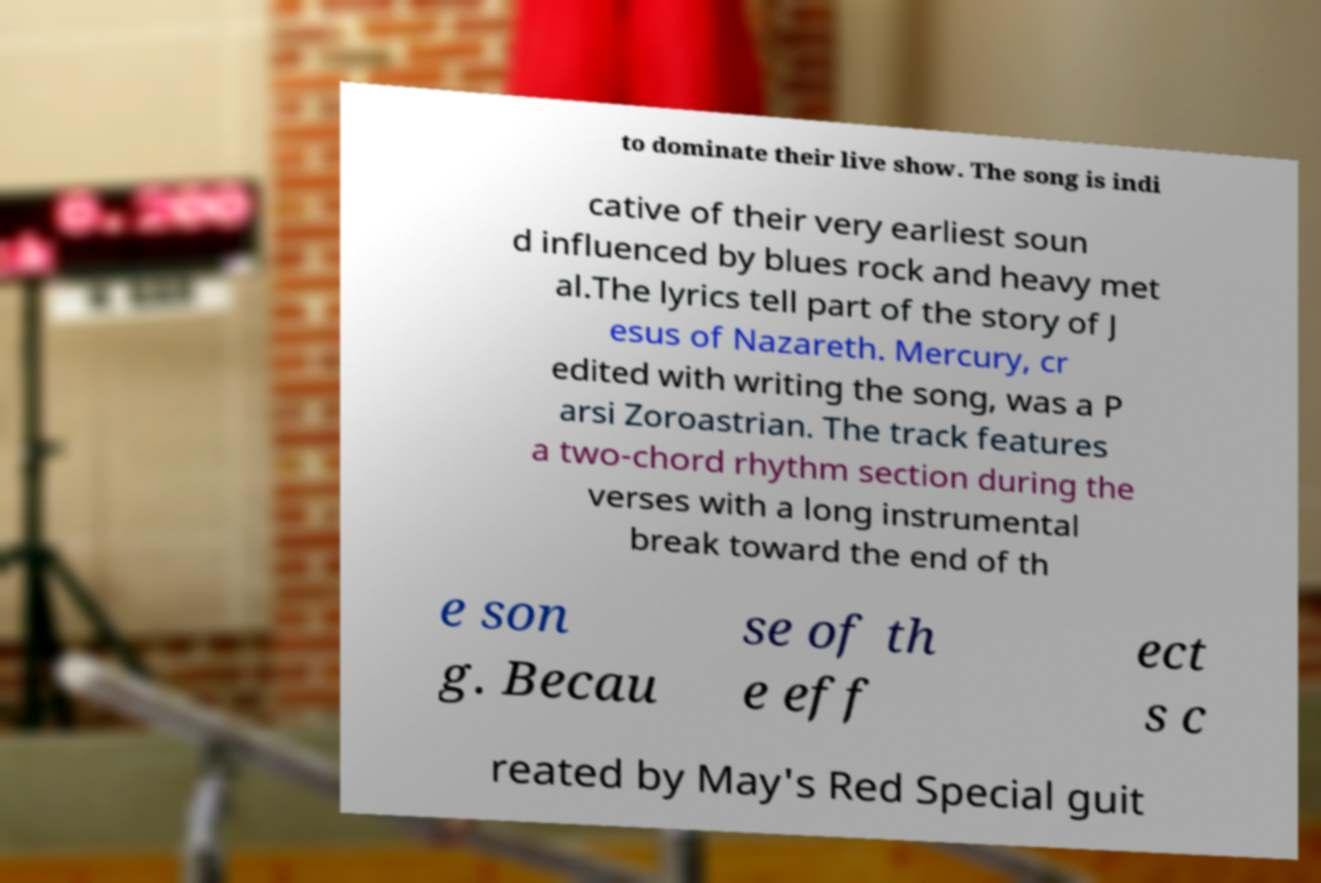There's text embedded in this image that I need extracted. Can you transcribe it verbatim? to dominate their live show. The song is indi cative of their very earliest soun d influenced by blues rock and heavy met al.The lyrics tell part of the story of J esus of Nazareth. Mercury, cr edited with writing the song, was a P arsi Zoroastrian. The track features a two-chord rhythm section during the verses with a long instrumental break toward the end of th e son g. Becau se of th e eff ect s c reated by May's Red Special guit 